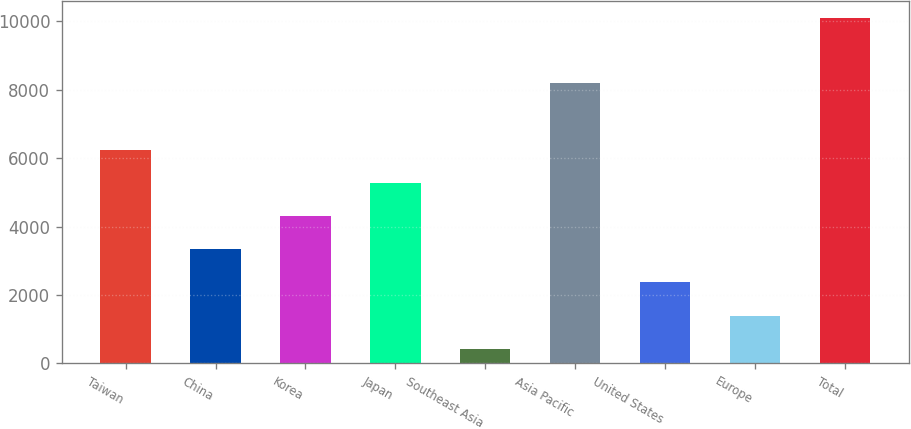Convert chart to OTSL. <chart><loc_0><loc_0><loc_500><loc_500><bar_chart><fcel>Taiwan<fcel>China<fcel>Korea<fcel>Japan<fcel>Southeast Asia<fcel>Asia Pacific<fcel>United States<fcel>Europe<fcel>Total<nl><fcel>6234.4<fcel>3332.2<fcel>4299.6<fcel>5267<fcel>430<fcel>8205<fcel>2364.8<fcel>1397.4<fcel>10104<nl></chart> 